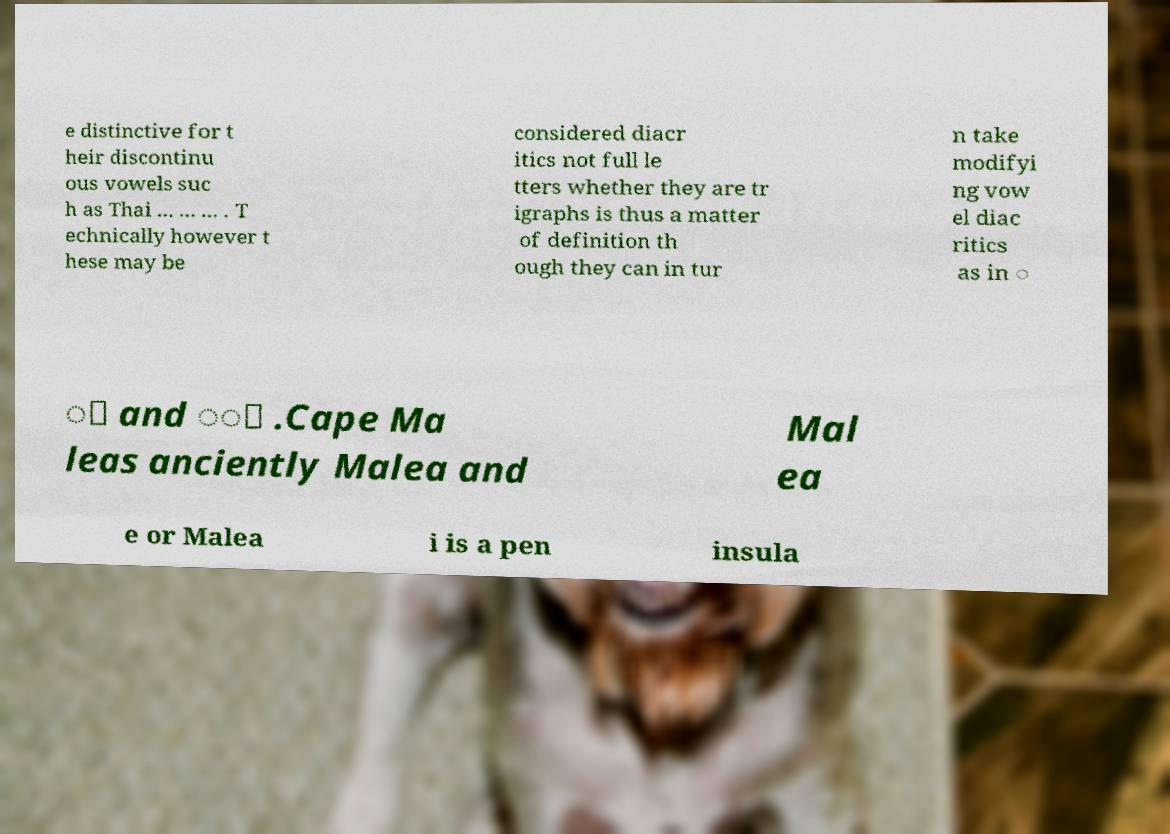There's text embedded in this image that I need extracted. Can you transcribe it verbatim? e distinctive for t heir discontinu ous vowels suc h as Thai ... ... ... . T echnically however t hese may be considered diacr itics not full le tters whether they are tr igraphs is thus a matter of definition th ough they can in tur n take modifyi ng vow el diac ritics as in ◌ ี and ◌ื .Cape Ma leas anciently Malea and Mal ea e or Malea i is a pen insula 